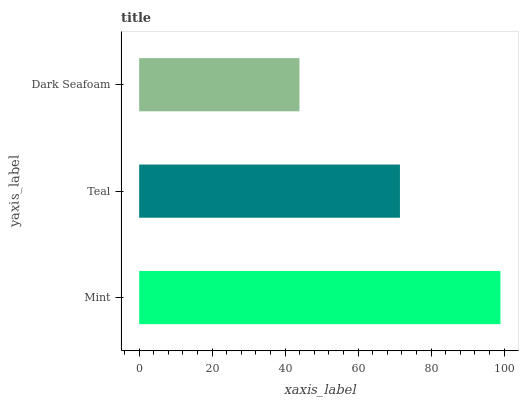Is Dark Seafoam the minimum?
Answer yes or no. Yes. Is Mint the maximum?
Answer yes or no. Yes. Is Teal the minimum?
Answer yes or no. No. Is Teal the maximum?
Answer yes or no. No. Is Mint greater than Teal?
Answer yes or no. Yes. Is Teal less than Mint?
Answer yes or no. Yes. Is Teal greater than Mint?
Answer yes or no. No. Is Mint less than Teal?
Answer yes or no. No. Is Teal the high median?
Answer yes or no. Yes. Is Teal the low median?
Answer yes or no. Yes. Is Mint the high median?
Answer yes or no. No. Is Dark Seafoam the low median?
Answer yes or no. No. 